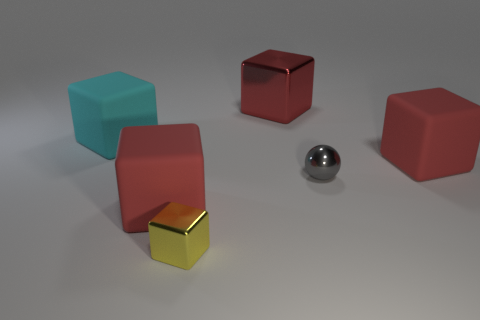There is a cube that is behind the cyan cube; is it the same color as the tiny thing left of the small gray sphere? No, the cube behind the cyan cube is not the same color as the tiny object to the left of the small gray sphere. The cube is red, whereas the tiny object appears to be a smaller, yellow cube. 